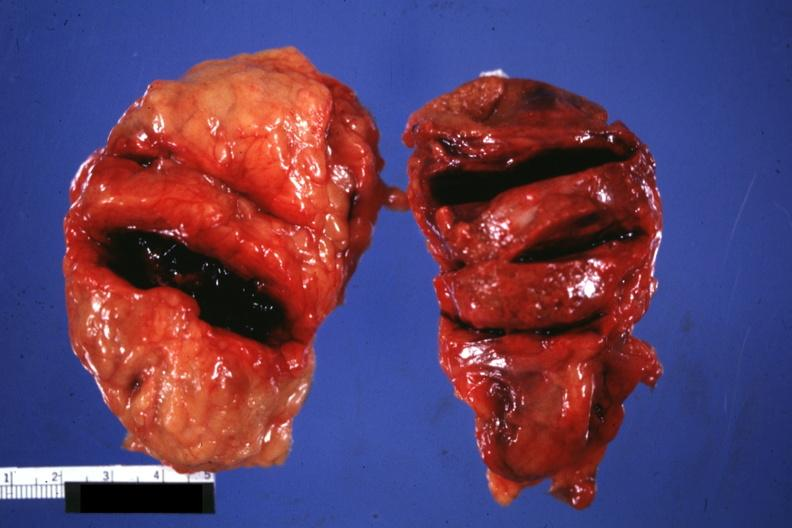does this image show external view of gland with knife cuts into parenchyma hemorrhage is obvious?
Answer the question using a single word or phrase. Yes 